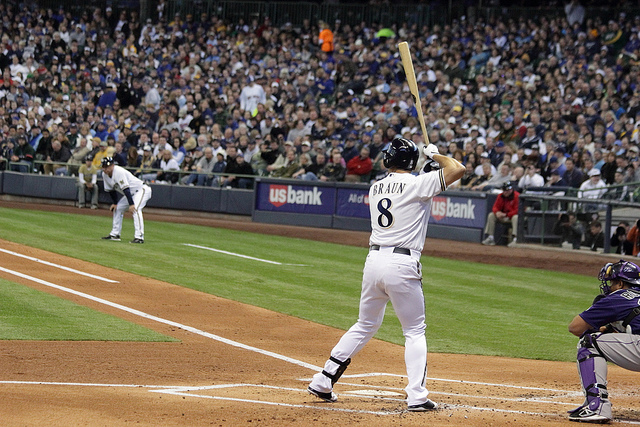What sport is being played in this image? The sport being played is baseball, which is evident from the batter's stance, the catcher's position, and the pitcher's posture.  Can you describe the atmosphere of the place where the game is being held? Certainly! The game is being held in a stadium filled with spectators. The environment appears lively and charged with excitement, typical of a professional baseball game. The seats are filled with fans, and the bright lights illuminate the field for an evening or night game. 